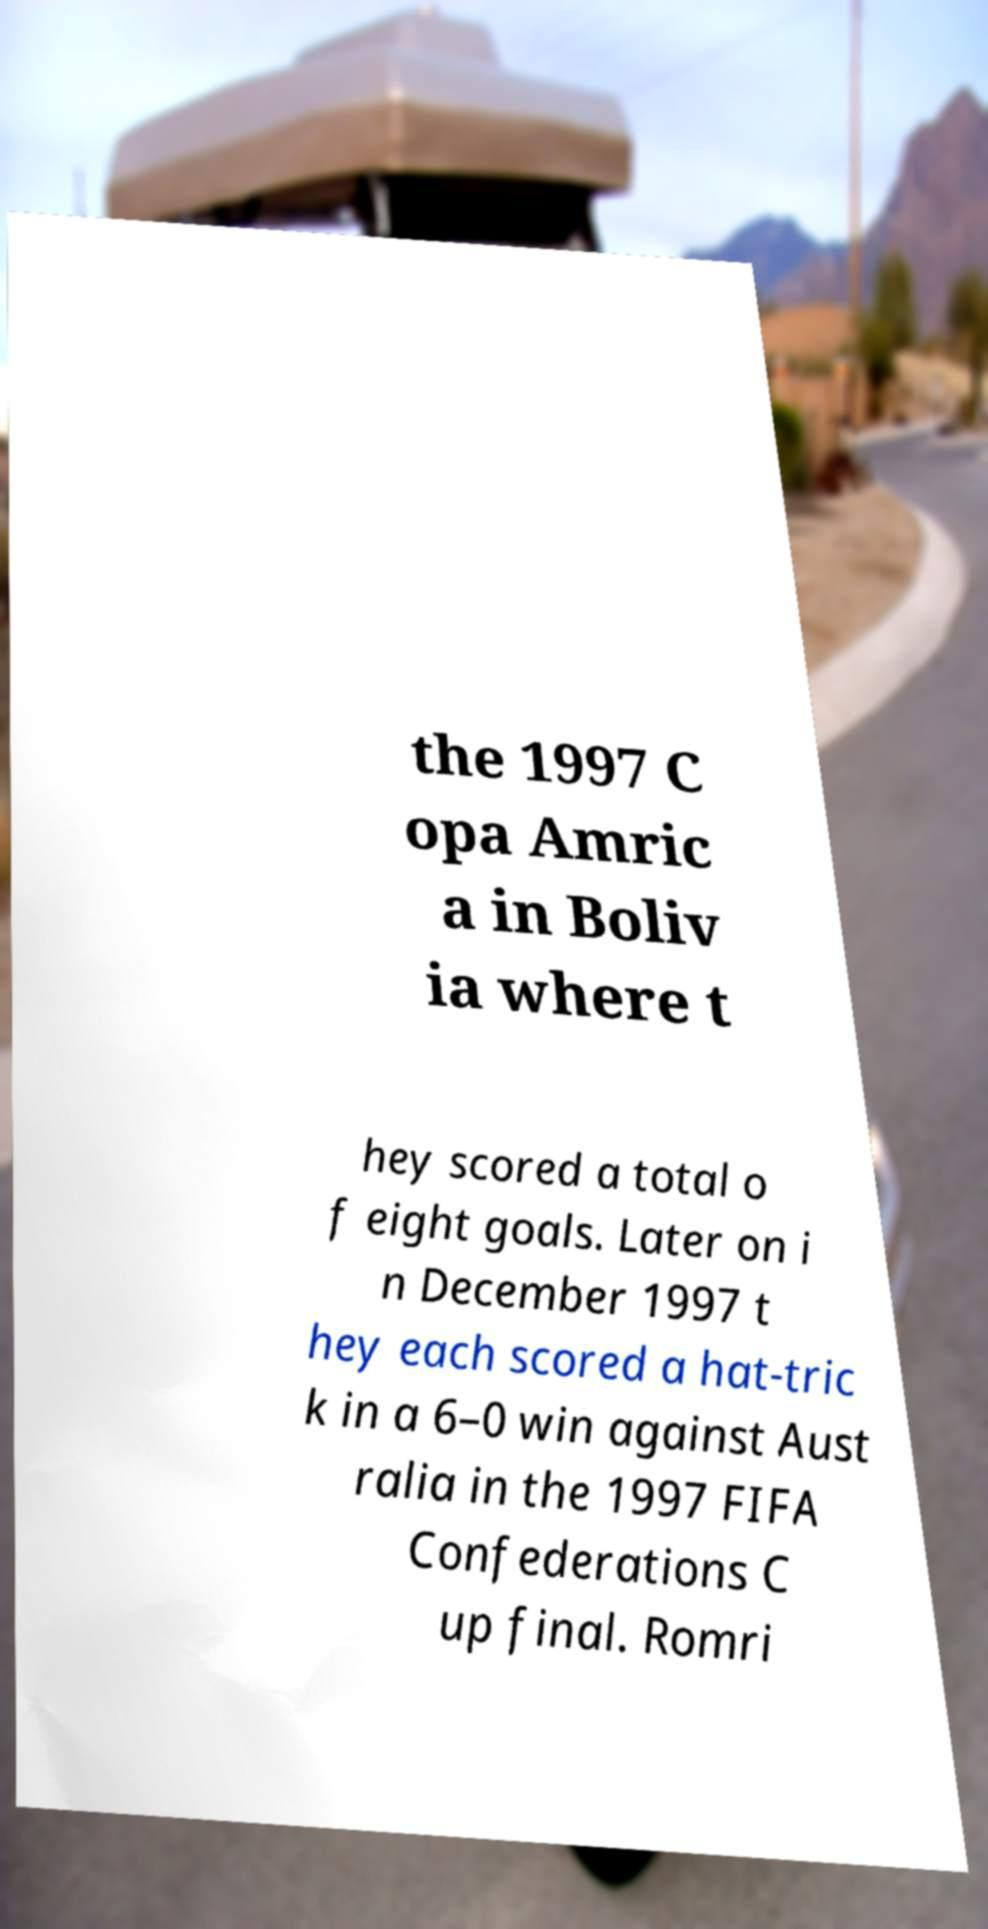There's text embedded in this image that I need extracted. Can you transcribe it verbatim? the 1997 C opa Amric a in Boliv ia where t hey scored a total o f eight goals. Later on i n December 1997 t hey each scored a hat-tric k in a 6–0 win against Aust ralia in the 1997 FIFA Confederations C up final. Romri 